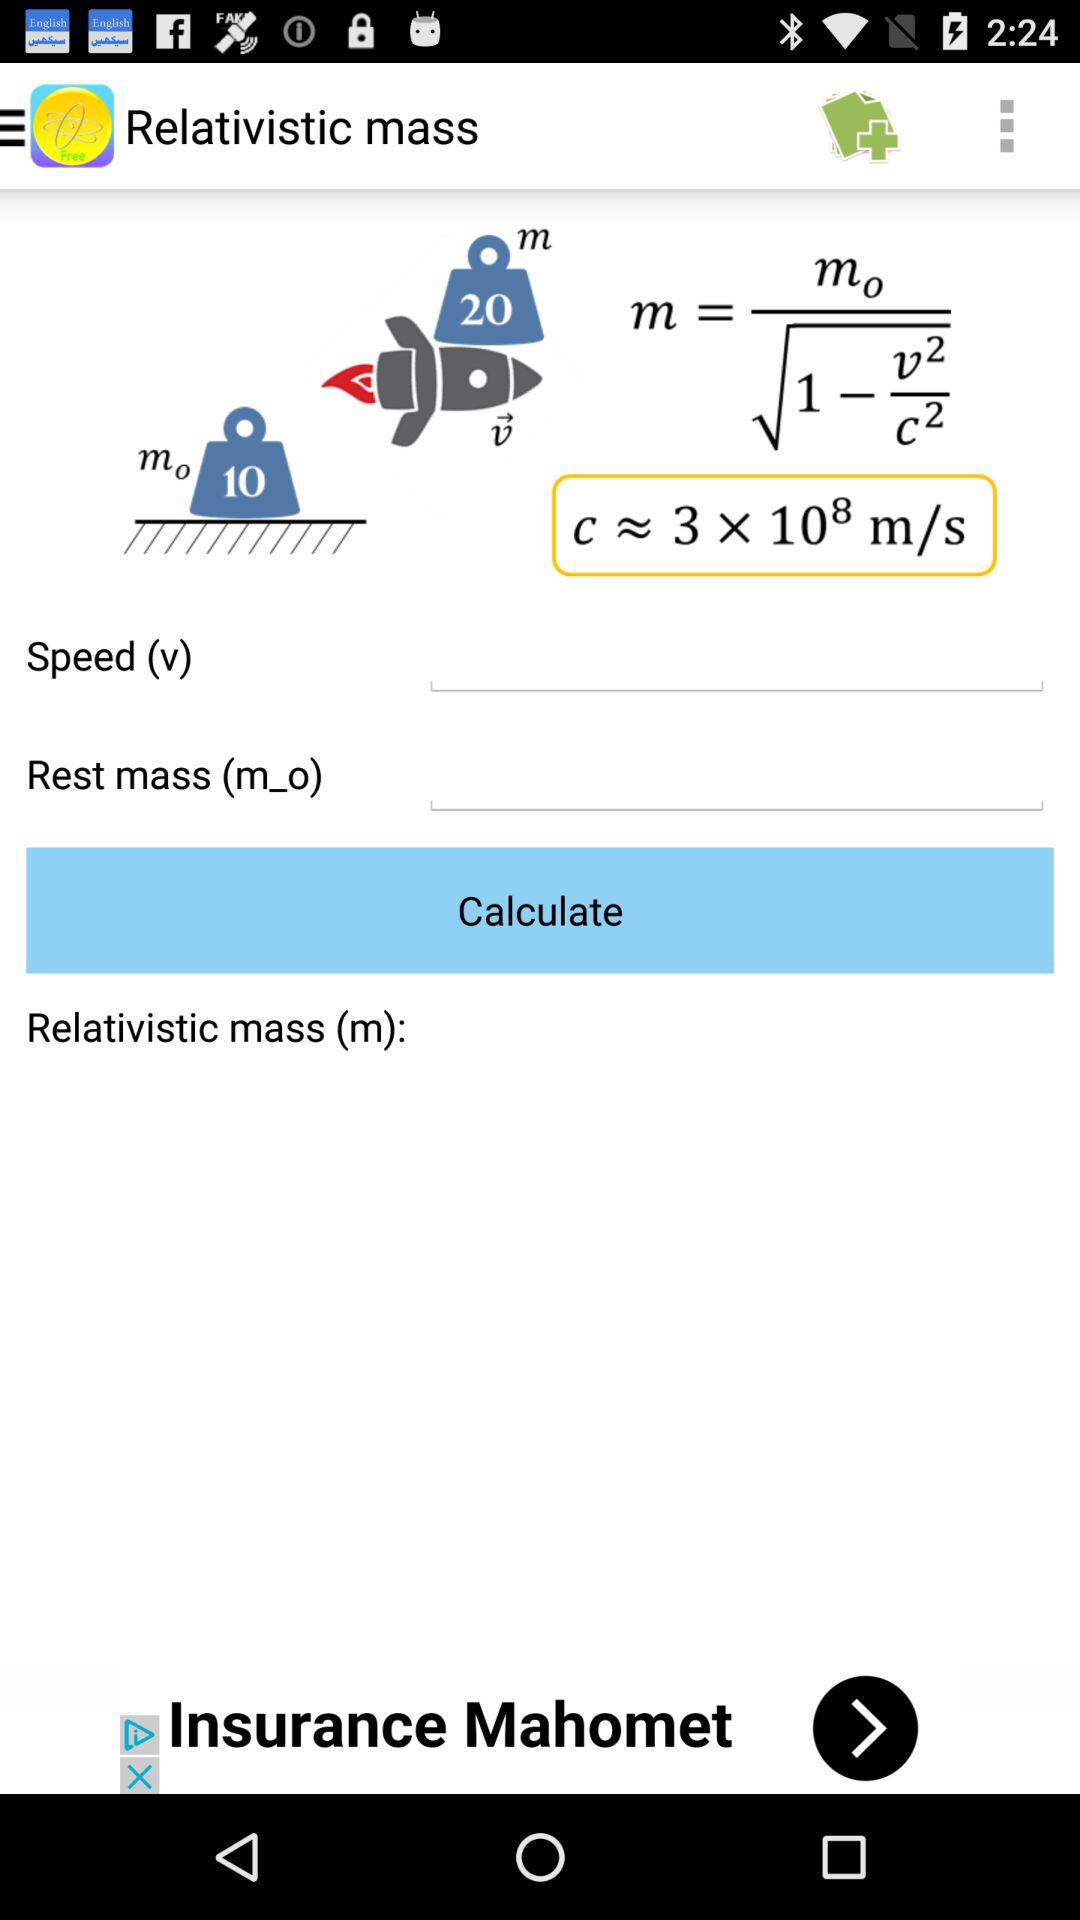What is the app name? The app name is "Relativistic mass". 